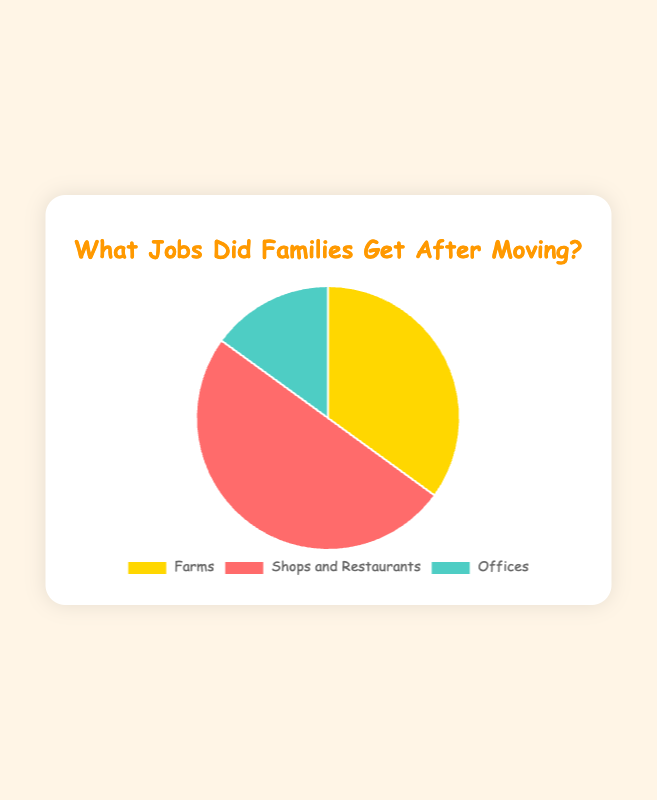What type of jobs do most families get after moving? The piece of the pie chart that represents the Service Industry is the largest, indicating that most families work in shops and restaurants after moving.
Answer: Service Industry (Shops and Restaurants) Which job group has the smallest number of families? The piece of the pie chart representing Professional jobs is the smallest, indicating that the fewest families work in offices.
Answer: Professional (Offices) How many more families work in shops and restaurants compared to farms? Subtract the number of families working in Agriculture from the number of families working in the Service Industry: 50 - 35 = 15.
Answer: 15 What is the total number of families? Add up the number of families in all employment types: 35 (Agriculture) + 50 (Service Industry) + 15 (Professional) = 100.
Answer: 100 What percentage of families work in offices? Divide the number of families working in Professional jobs by the total number of families, then multiply by 100 to get the percentage: (15 / 100) * 100 = 15%.
Answer: 15% Are there more families working in farms and offices combined than in shops and restaurants? Add the number of families working in Agriculture and Professional jobs: 35 + 15 = 50, which is equal to the number of families working in the Service Industry (50).
Answer: Equal Which color represents the families working on farms? The section representing Agriculture is colored yellow in the pie chart.
Answer: Yellow How many families work in jobs outside of shops and restaurants? Add the number of families working in Agriculture and Professional jobs: 35 (Agriculture) + 15 (Professional) = 50.
Answer: 50 What is the difference between the number of families working in the most common job type and the least common job type? Subtract the number of families working in Professional jobs from those in the Service Industry: 50 - 15 = 35.
Answer: 35 If Agriculture and Professional jobs combined are grouped together, by what percentage would the Service Industry outnumber this new group? Add the families in Agriculture and Professional jobs: 35 + 15 = 50. The Service Industry has 50 families, which is 0% more than the combined Agriculture and Professional groups since 50/50 * 100 - 100 = 0%.
Answer: 0% 